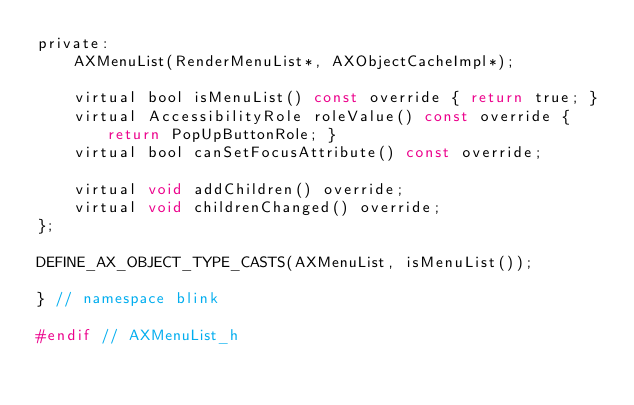Convert code to text. <code><loc_0><loc_0><loc_500><loc_500><_C_>private:
    AXMenuList(RenderMenuList*, AXObjectCacheImpl*);

    virtual bool isMenuList() const override { return true; }
    virtual AccessibilityRole roleValue() const override { return PopUpButtonRole; }
    virtual bool canSetFocusAttribute() const override;

    virtual void addChildren() override;
    virtual void childrenChanged() override;
};

DEFINE_AX_OBJECT_TYPE_CASTS(AXMenuList, isMenuList());

} // namespace blink

#endif // AXMenuList_h
</code> 